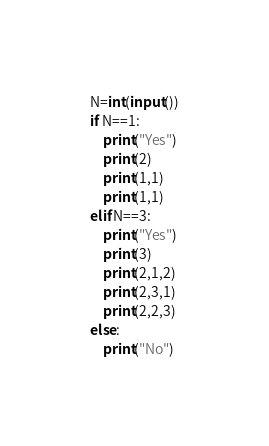Convert code to text. <code><loc_0><loc_0><loc_500><loc_500><_Python_>N=int(input())
if N==1:
    print("Yes")
    print(2)
    print(1,1)
    print(1,1)
elif N==3:
    print("Yes")
    print(3)
    print(2,1,2)
    print(2,3,1)
    print(2,2,3)
else:
    print("No")
</code> 